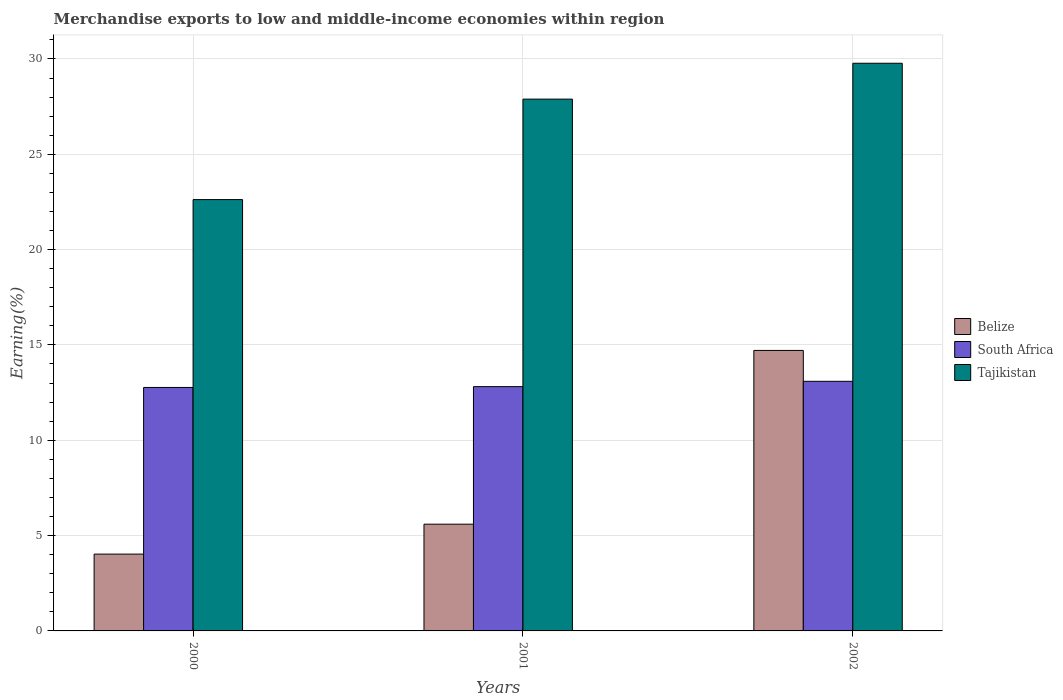How many bars are there on the 2nd tick from the left?
Offer a very short reply. 3. How many bars are there on the 1st tick from the right?
Provide a short and direct response. 3. In how many cases, is the number of bars for a given year not equal to the number of legend labels?
Offer a very short reply. 0. What is the percentage of amount earned from merchandise exports in South Africa in 2001?
Ensure brevity in your answer.  12.81. Across all years, what is the maximum percentage of amount earned from merchandise exports in South Africa?
Make the answer very short. 13.09. Across all years, what is the minimum percentage of amount earned from merchandise exports in South Africa?
Offer a terse response. 12.77. In which year was the percentage of amount earned from merchandise exports in Belize maximum?
Your answer should be compact. 2002. What is the total percentage of amount earned from merchandise exports in South Africa in the graph?
Offer a terse response. 38.67. What is the difference between the percentage of amount earned from merchandise exports in Belize in 2000 and that in 2002?
Your answer should be very brief. -10.68. What is the difference between the percentage of amount earned from merchandise exports in Belize in 2000 and the percentage of amount earned from merchandise exports in Tajikistan in 2002?
Your answer should be very brief. -25.74. What is the average percentage of amount earned from merchandise exports in Belize per year?
Give a very brief answer. 8.11. In the year 2001, what is the difference between the percentage of amount earned from merchandise exports in Tajikistan and percentage of amount earned from merchandise exports in Belize?
Offer a terse response. 22.29. In how many years, is the percentage of amount earned from merchandise exports in Tajikistan greater than 5 %?
Your answer should be very brief. 3. What is the ratio of the percentage of amount earned from merchandise exports in Belize in 2000 to that in 2002?
Give a very brief answer. 0.27. Is the percentage of amount earned from merchandise exports in South Africa in 2000 less than that in 2002?
Provide a succinct answer. Yes. Is the difference between the percentage of amount earned from merchandise exports in Tajikistan in 2000 and 2002 greater than the difference between the percentage of amount earned from merchandise exports in Belize in 2000 and 2002?
Your response must be concise. Yes. What is the difference between the highest and the second highest percentage of amount earned from merchandise exports in Tajikistan?
Give a very brief answer. 1.88. What is the difference between the highest and the lowest percentage of amount earned from merchandise exports in Tajikistan?
Provide a succinct answer. 7.15. Is the sum of the percentage of amount earned from merchandise exports in Tajikistan in 2000 and 2002 greater than the maximum percentage of amount earned from merchandise exports in South Africa across all years?
Your answer should be compact. Yes. What does the 2nd bar from the left in 2002 represents?
Your answer should be compact. South Africa. What does the 3rd bar from the right in 2002 represents?
Provide a short and direct response. Belize. Are all the bars in the graph horizontal?
Ensure brevity in your answer.  No. How many years are there in the graph?
Make the answer very short. 3. What is the difference between two consecutive major ticks on the Y-axis?
Offer a terse response. 5. How many legend labels are there?
Keep it short and to the point. 3. How are the legend labels stacked?
Your response must be concise. Vertical. What is the title of the graph?
Make the answer very short. Merchandise exports to low and middle-income economies within region. Does "Russian Federation" appear as one of the legend labels in the graph?
Offer a very short reply. No. What is the label or title of the X-axis?
Keep it short and to the point. Years. What is the label or title of the Y-axis?
Your answer should be very brief. Earning(%). What is the Earning(%) in Belize in 2000?
Give a very brief answer. 4.03. What is the Earning(%) of South Africa in 2000?
Your answer should be very brief. 12.77. What is the Earning(%) in Tajikistan in 2000?
Provide a succinct answer. 22.62. What is the Earning(%) of Belize in 2001?
Provide a short and direct response. 5.6. What is the Earning(%) of South Africa in 2001?
Offer a terse response. 12.81. What is the Earning(%) of Tajikistan in 2001?
Your answer should be compact. 27.89. What is the Earning(%) in Belize in 2002?
Offer a very short reply. 14.71. What is the Earning(%) of South Africa in 2002?
Offer a terse response. 13.09. What is the Earning(%) in Tajikistan in 2002?
Your answer should be compact. 29.77. Across all years, what is the maximum Earning(%) of Belize?
Offer a very short reply. 14.71. Across all years, what is the maximum Earning(%) of South Africa?
Offer a terse response. 13.09. Across all years, what is the maximum Earning(%) in Tajikistan?
Offer a terse response. 29.77. Across all years, what is the minimum Earning(%) in Belize?
Offer a very short reply. 4.03. Across all years, what is the minimum Earning(%) in South Africa?
Your answer should be very brief. 12.77. Across all years, what is the minimum Earning(%) of Tajikistan?
Provide a succinct answer. 22.62. What is the total Earning(%) of Belize in the graph?
Your answer should be very brief. 24.34. What is the total Earning(%) of South Africa in the graph?
Your answer should be compact. 38.67. What is the total Earning(%) in Tajikistan in the graph?
Offer a terse response. 80.29. What is the difference between the Earning(%) of Belize in 2000 and that in 2001?
Provide a succinct answer. -1.57. What is the difference between the Earning(%) in South Africa in 2000 and that in 2001?
Offer a very short reply. -0.04. What is the difference between the Earning(%) in Tajikistan in 2000 and that in 2001?
Offer a very short reply. -5.27. What is the difference between the Earning(%) of Belize in 2000 and that in 2002?
Your answer should be very brief. -10.68. What is the difference between the Earning(%) in South Africa in 2000 and that in 2002?
Your answer should be compact. -0.32. What is the difference between the Earning(%) of Tajikistan in 2000 and that in 2002?
Your answer should be very brief. -7.15. What is the difference between the Earning(%) in Belize in 2001 and that in 2002?
Provide a short and direct response. -9.11. What is the difference between the Earning(%) in South Africa in 2001 and that in 2002?
Your response must be concise. -0.28. What is the difference between the Earning(%) in Tajikistan in 2001 and that in 2002?
Ensure brevity in your answer.  -1.88. What is the difference between the Earning(%) of Belize in 2000 and the Earning(%) of South Africa in 2001?
Make the answer very short. -8.78. What is the difference between the Earning(%) in Belize in 2000 and the Earning(%) in Tajikistan in 2001?
Provide a succinct answer. -23.86. What is the difference between the Earning(%) in South Africa in 2000 and the Earning(%) in Tajikistan in 2001?
Your answer should be very brief. -15.12. What is the difference between the Earning(%) in Belize in 2000 and the Earning(%) in South Africa in 2002?
Give a very brief answer. -9.06. What is the difference between the Earning(%) in Belize in 2000 and the Earning(%) in Tajikistan in 2002?
Your answer should be compact. -25.74. What is the difference between the Earning(%) of South Africa in 2000 and the Earning(%) of Tajikistan in 2002?
Your response must be concise. -17. What is the difference between the Earning(%) of Belize in 2001 and the Earning(%) of South Africa in 2002?
Ensure brevity in your answer.  -7.49. What is the difference between the Earning(%) in Belize in 2001 and the Earning(%) in Tajikistan in 2002?
Your response must be concise. -24.18. What is the difference between the Earning(%) in South Africa in 2001 and the Earning(%) in Tajikistan in 2002?
Make the answer very short. -16.96. What is the average Earning(%) of Belize per year?
Offer a terse response. 8.11. What is the average Earning(%) in South Africa per year?
Make the answer very short. 12.89. What is the average Earning(%) in Tajikistan per year?
Keep it short and to the point. 26.76. In the year 2000, what is the difference between the Earning(%) of Belize and Earning(%) of South Africa?
Provide a short and direct response. -8.74. In the year 2000, what is the difference between the Earning(%) of Belize and Earning(%) of Tajikistan?
Offer a very short reply. -18.59. In the year 2000, what is the difference between the Earning(%) of South Africa and Earning(%) of Tajikistan?
Make the answer very short. -9.85. In the year 2001, what is the difference between the Earning(%) of Belize and Earning(%) of South Africa?
Give a very brief answer. -7.21. In the year 2001, what is the difference between the Earning(%) of Belize and Earning(%) of Tajikistan?
Ensure brevity in your answer.  -22.29. In the year 2001, what is the difference between the Earning(%) of South Africa and Earning(%) of Tajikistan?
Make the answer very short. -15.08. In the year 2002, what is the difference between the Earning(%) in Belize and Earning(%) in South Africa?
Your answer should be very brief. 1.62. In the year 2002, what is the difference between the Earning(%) in Belize and Earning(%) in Tajikistan?
Keep it short and to the point. -15.06. In the year 2002, what is the difference between the Earning(%) in South Africa and Earning(%) in Tajikistan?
Ensure brevity in your answer.  -16.68. What is the ratio of the Earning(%) in Belize in 2000 to that in 2001?
Your answer should be compact. 0.72. What is the ratio of the Earning(%) in Tajikistan in 2000 to that in 2001?
Offer a very short reply. 0.81. What is the ratio of the Earning(%) of Belize in 2000 to that in 2002?
Ensure brevity in your answer.  0.27. What is the ratio of the Earning(%) of South Africa in 2000 to that in 2002?
Ensure brevity in your answer.  0.98. What is the ratio of the Earning(%) in Tajikistan in 2000 to that in 2002?
Your response must be concise. 0.76. What is the ratio of the Earning(%) in Belize in 2001 to that in 2002?
Your answer should be very brief. 0.38. What is the ratio of the Earning(%) in South Africa in 2001 to that in 2002?
Your response must be concise. 0.98. What is the ratio of the Earning(%) of Tajikistan in 2001 to that in 2002?
Your answer should be very brief. 0.94. What is the difference between the highest and the second highest Earning(%) in Belize?
Provide a succinct answer. 9.11. What is the difference between the highest and the second highest Earning(%) in South Africa?
Offer a very short reply. 0.28. What is the difference between the highest and the second highest Earning(%) in Tajikistan?
Ensure brevity in your answer.  1.88. What is the difference between the highest and the lowest Earning(%) of Belize?
Keep it short and to the point. 10.68. What is the difference between the highest and the lowest Earning(%) of South Africa?
Offer a terse response. 0.32. What is the difference between the highest and the lowest Earning(%) in Tajikistan?
Offer a terse response. 7.15. 